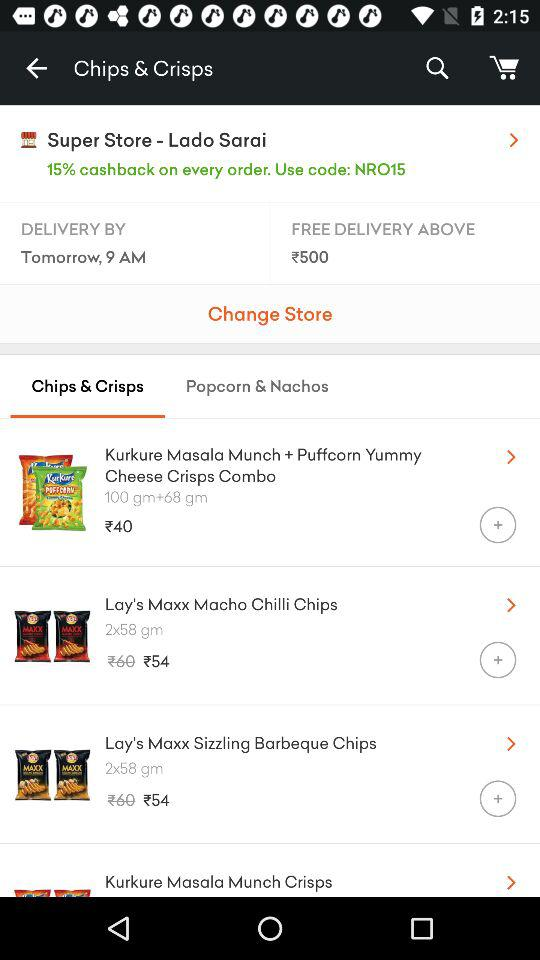What is the code? The code is NRO15. 